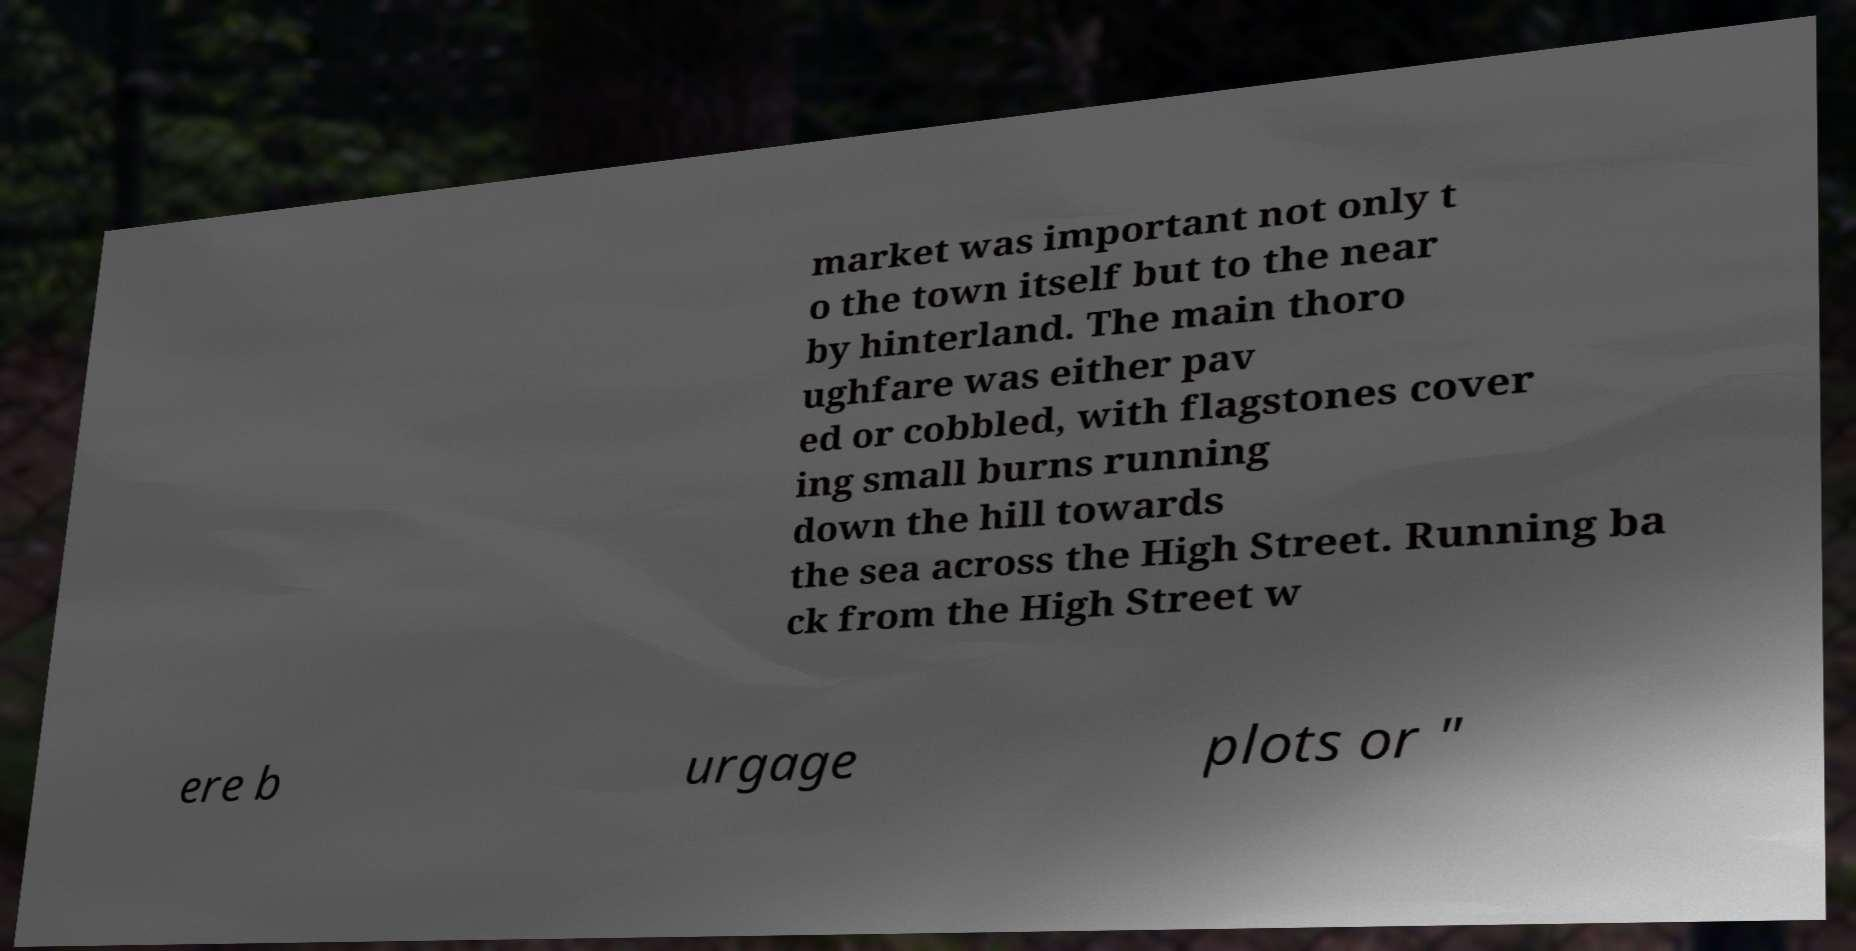I need the written content from this picture converted into text. Can you do that? market was important not only t o the town itself but to the near by hinterland. The main thoro ughfare was either pav ed or cobbled, with flagstones cover ing small burns running down the hill towards the sea across the High Street. Running ba ck from the High Street w ere b urgage plots or " 